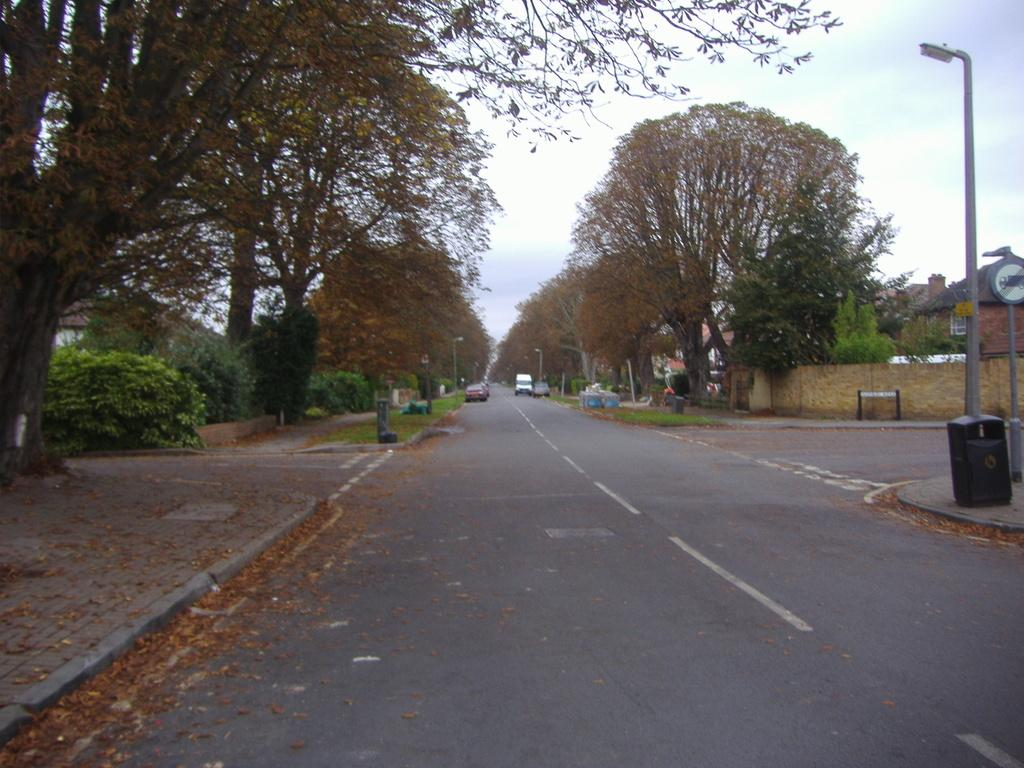What can be seen on the road in the image? There are vehicles on the road in the image. What is present on the pavement on either side of the road? There are lamp posts and trash cans on the pavement on either side of the road. What type of vegetation is visible beside the pavement? There are trees beside the pavement. What type of structures can be seen in the image? There are houses visible in the image. What type of plant is growing on the angle of the roof in the image? There is no plant growing on the angle of a roof in the image; the image does not show any roofs. What type of knowledge can be gained from the image? The image provides visual information about the presence of vehicles, lamp posts, trash cans, trees, and houses, but it does not convey any specific knowledge or teach any lessons. 